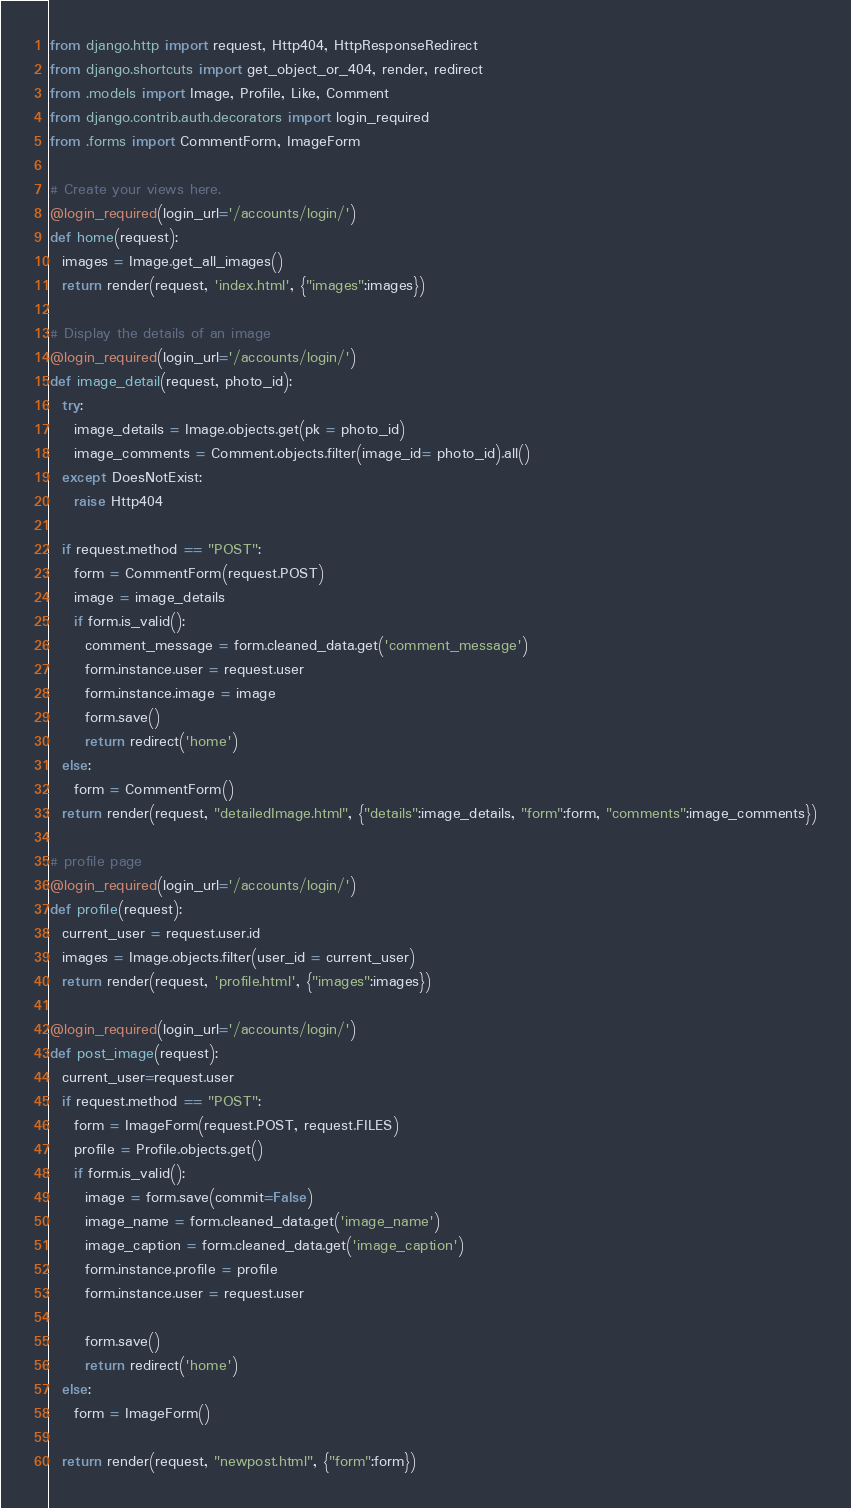<code> <loc_0><loc_0><loc_500><loc_500><_Python_>from django.http import request, Http404, HttpResponseRedirect
from django.shortcuts import get_object_or_404, render, redirect
from .models import Image, Profile, Like, Comment
from django.contrib.auth.decorators import login_required
from .forms import CommentForm, ImageForm

# Create your views here.
@login_required(login_url='/accounts/login/')
def home(request):
  images = Image.get_all_images()
  return render(request, 'index.html', {"images":images})

# Display the details of an image
@login_required(login_url='/accounts/login/')
def image_detail(request, photo_id):
  try:
    image_details = Image.objects.get(pk = photo_id)
    image_comments = Comment.objects.filter(image_id= photo_id).all()
  except DoesNotExist:
    raise Http404

  if request.method == "POST":
    form = CommentForm(request.POST)
    image = image_details
    if form.is_valid():
      comment_message = form.cleaned_data.get('comment_message')
      form.instance.user = request.user
      form.instance.image = image
      form.save()
      return redirect('home')
  else:
    form = CommentForm()
  return render(request, "detailedImage.html", {"details":image_details, "form":form, "comments":image_comments})

# profile page
@login_required(login_url='/accounts/login/')
def profile(request):
  current_user = request.user.id
  images = Image.objects.filter(user_id = current_user)
  return render(request, 'profile.html', {"images":images})

@login_required(login_url='/accounts/login/')
def post_image(request):
  current_user=request.user
  if request.method == "POST":
    form = ImageForm(request.POST, request.FILES)
    profile = Profile.objects.get()
    if form.is_valid():
      image = form.save(commit=False)
      image_name = form.cleaned_data.get('image_name')
      image_caption = form.cleaned_data.get('image_caption')
      form.instance.profile = profile
      form.instance.user = request.user
      
      form.save()
      return redirect('home')
  else:
    form = ImageForm()
    
  return render(request, "newpost.html", {"form":form})</code> 